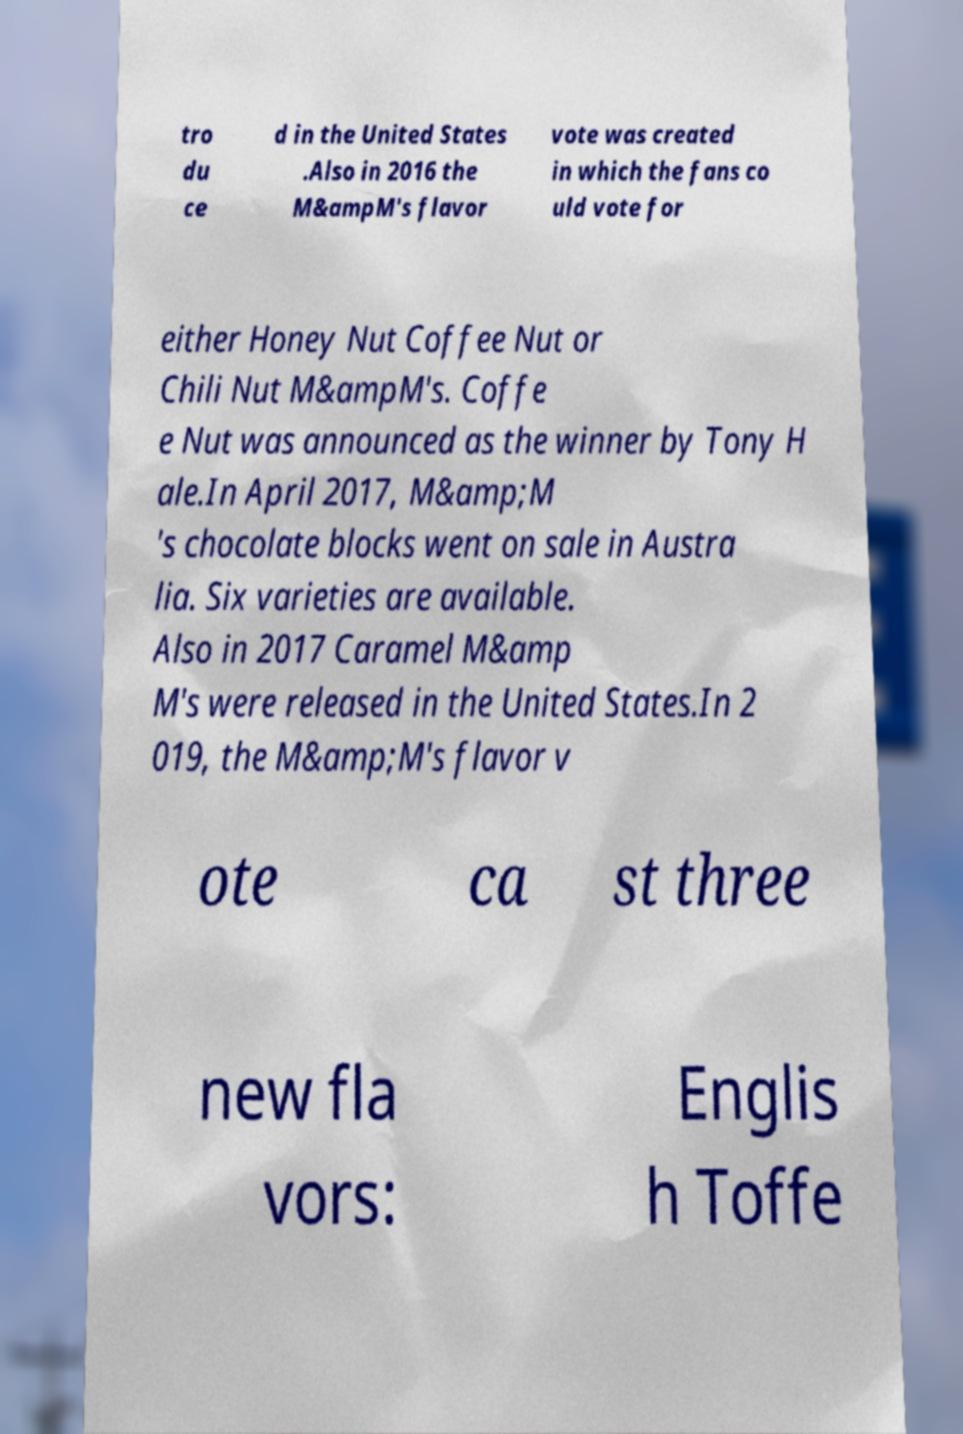What messages or text are displayed in this image? I need them in a readable, typed format. tro du ce d in the United States .Also in 2016 the M&ampM's flavor vote was created in which the fans co uld vote for either Honey Nut Coffee Nut or Chili Nut M&ampM's. Coffe e Nut was announced as the winner by Tony H ale.In April 2017, M&amp;M 's chocolate blocks went on sale in Austra lia. Six varieties are available. Also in 2017 Caramel M&amp M's were released in the United States.In 2 019, the M&amp;M's flavor v ote ca st three new fla vors: Englis h Toffe 